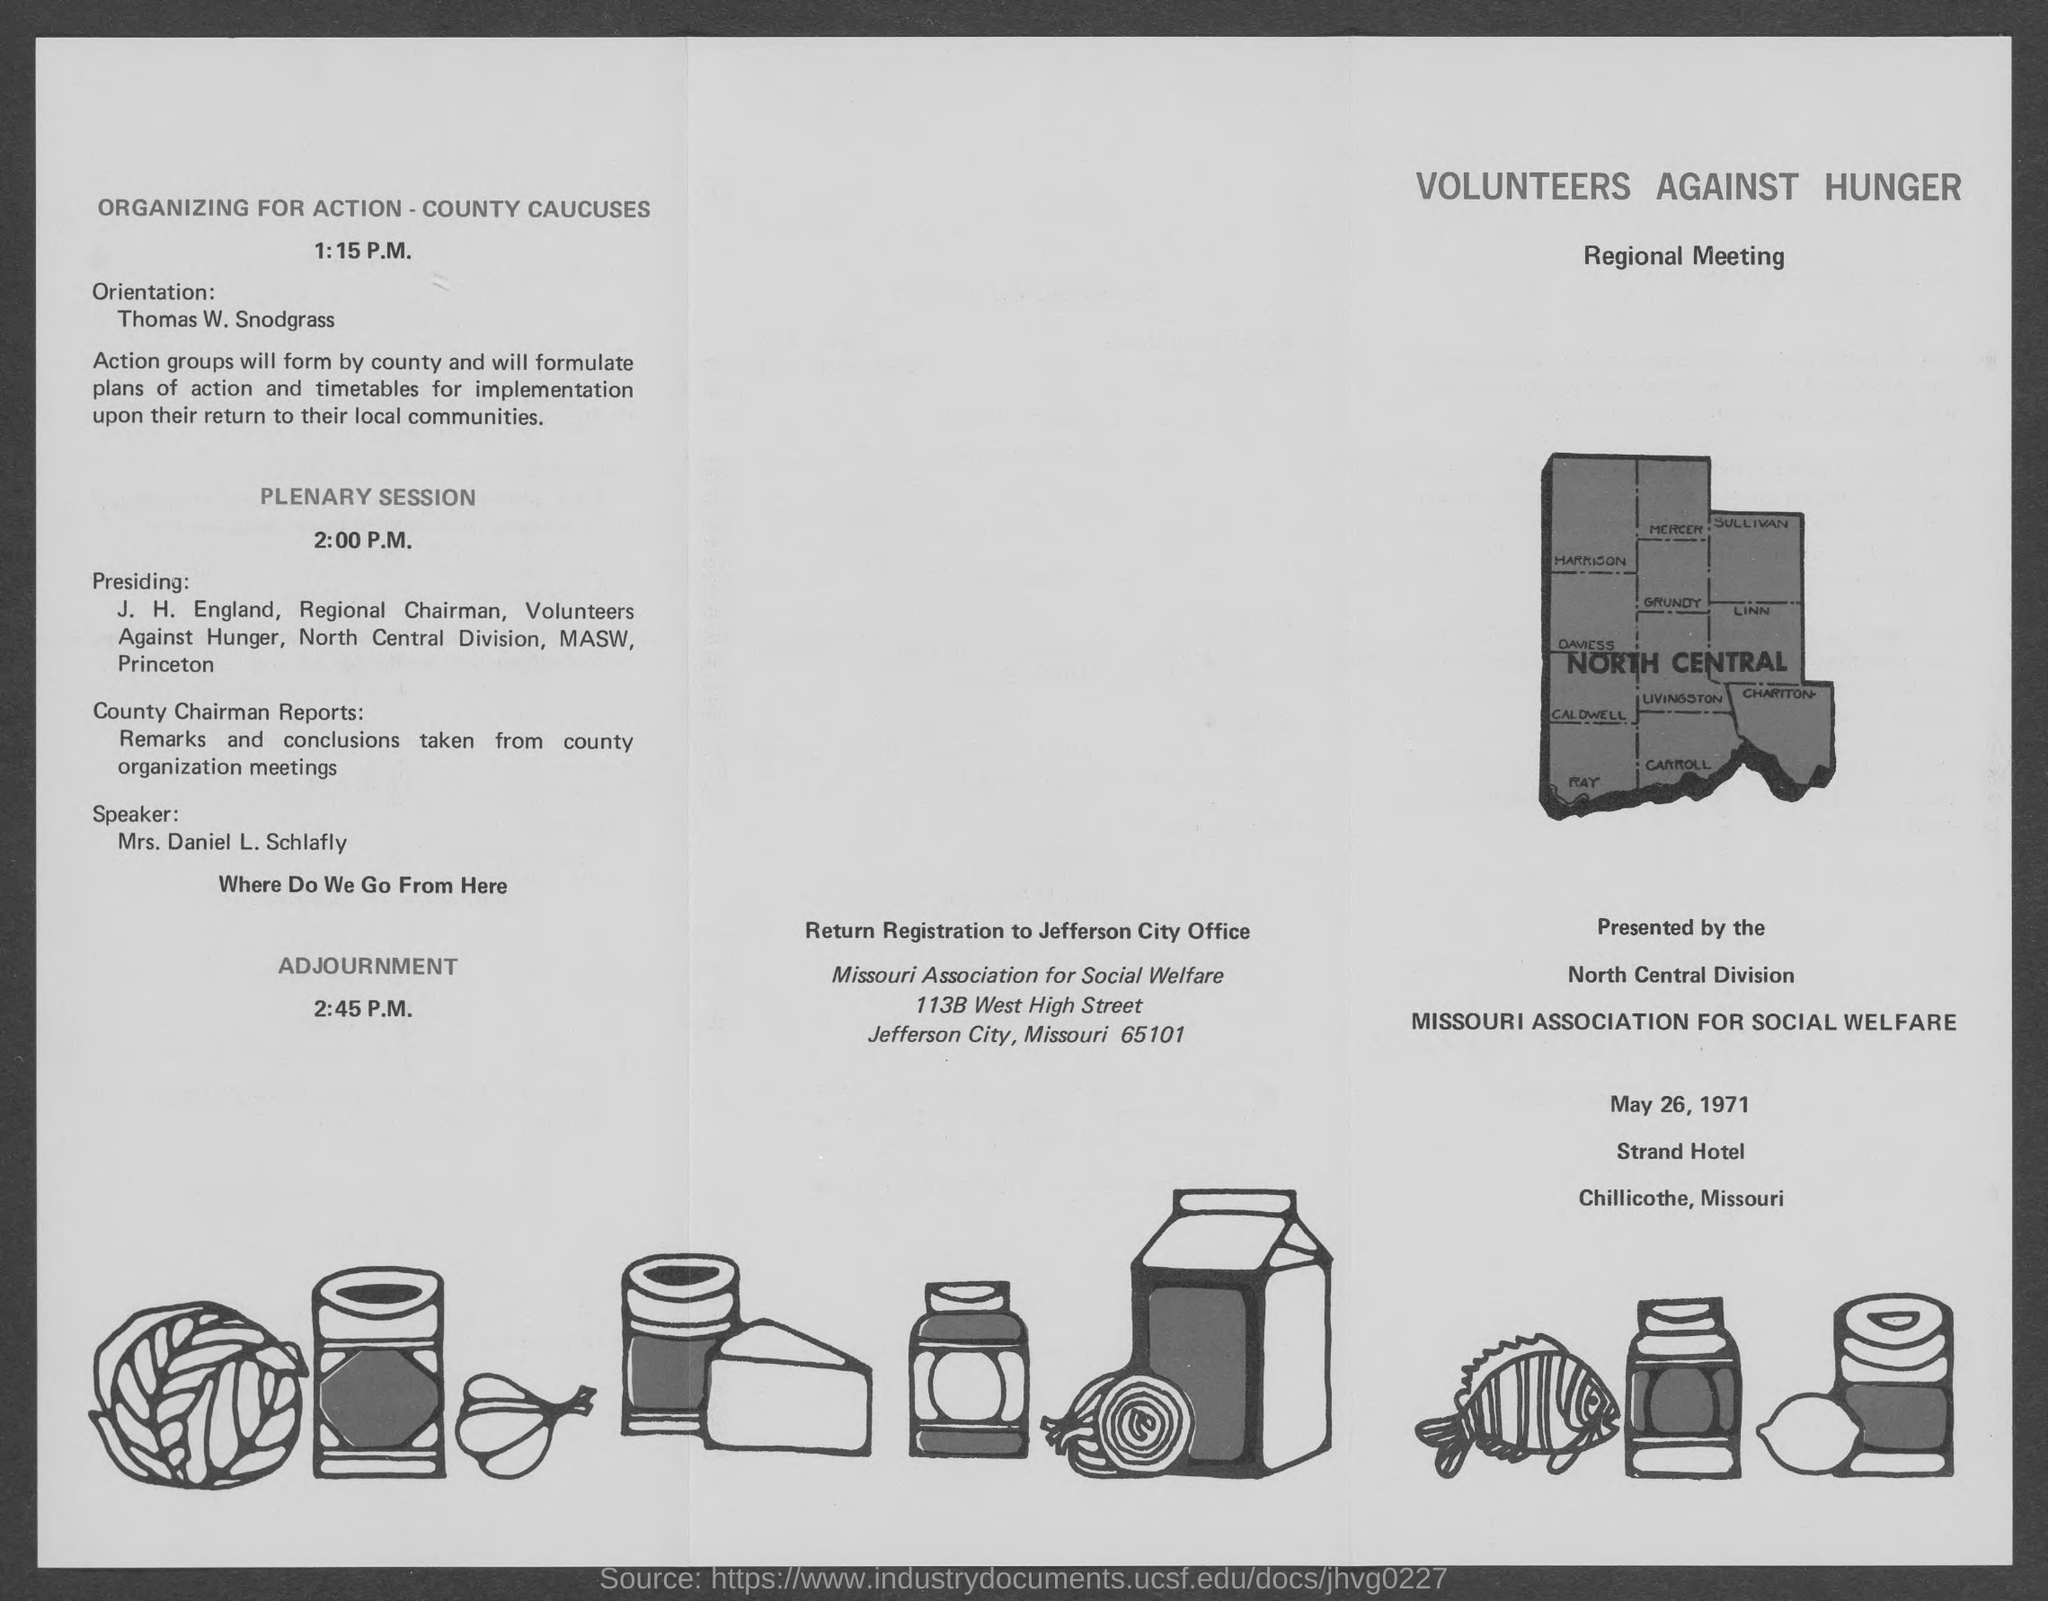Give some essential details in this illustration. The speaker is announcing the name of the person who will be presiding over a specific event. The speaker is J.H. England, the Regional Chairman. The speaker for the plenary session is Mrs. Daniel L. Schlafly. The regional meeting is scheduled to be held on May 26, 1971. The orientation is conducted by Thomas W. Snodgrass. The plenary session will take place at 2:00 P.M. 